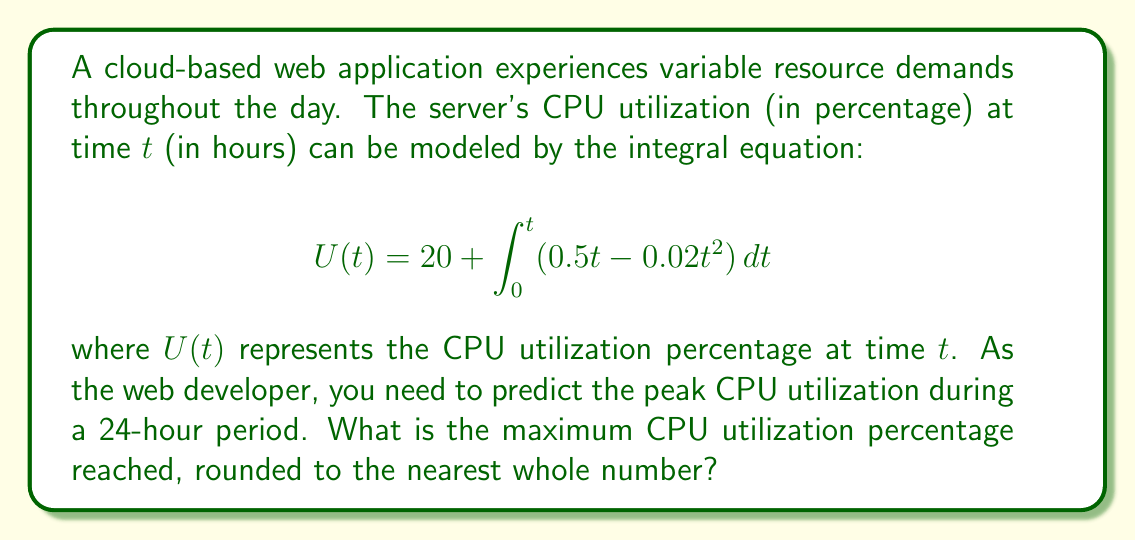Solve this math problem. To solve this problem, we'll follow these steps:

1) First, we need to solve the integral equation to get an explicit function for U(t):

   $$U(t) = 20 + \int_0^t (0.5t - 0.02t^2) dt$$
   
   $$U(t) = 20 + [0.25t^2 - \frac{0.02}{3}t^3]_0^t$$
   
   $$U(t) = 20 + (0.25t^2 - \frac{0.02}{3}t^3) - (0)$$
   
   $$U(t) = 20 + 0.25t^2 - \frac{0.02}{3}t^3$$

2) To find the maximum value, we need to find where the derivative of U(t) equals zero:

   $$U'(t) = 0.5t - 0.02t^2$$
   
   Set this equal to zero:
   
   $$0.5t - 0.02t^2 = 0$$
   
   $$t(0.5 - 0.02t) = 0$$
   
   $$t = 0$$ or $$0.5 - 0.02t = 0$$
   
   Solving the second equation:
   
   $$0.5 = 0.02t$$
   
   $$t = 25$$

3) The critical points are at t = 0 and t = 25. Since we're only interested in a 24-hour period, we need to check U(0), U(24), and U(25):

   $$U(0) = 20$$
   
   $$U(24) = 20 + 0.25(24)^2 - \frac{0.02}{3}(24)^3 = 44$$
   
   $$U(25) = 20 + 0.25(25)^2 - \frac{0.02}{3}(25)^3 = 45.83$$

4) The maximum value in the 24-hour period is 44 at t = 24.

5) Rounding to the nearest whole number, we get 44%.
Answer: 44% 